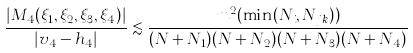<formula> <loc_0><loc_0><loc_500><loc_500>\frac { | M _ { 4 } ( \xi _ { 1 } , \xi _ { 2 } , \xi _ { 3 } , \xi _ { 4 } ) | } { | v _ { 4 } - h _ { 4 } | } \lesssim \frac { m ^ { 2 } ( \min ( N _ { i } , N _ { j k } ) ) } { ( N + N _ { 1 } ) ( N + N _ { 2 } ) ( N + N _ { 3 } ) ( N + N _ { 4 } ) }</formula> 